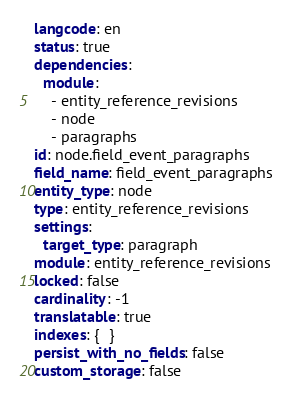Convert code to text. <code><loc_0><loc_0><loc_500><loc_500><_YAML_>langcode: en
status: true
dependencies:
  module:
    - entity_reference_revisions
    - node
    - paragraphs
id: node.field_event_paragraphs
field_name: field_event_paragraphs
entity_type: node
type: entity_reference_revisions
settings:
  target_type: paragraph
module: entity_reference_revisions
locked: false
cardinality: -1
translatable: true
indexes: {  }
persist_with_no_fields: false
custom_storage: false
</code> 